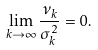Convert formula to latex. <formula><loc_0><loc_0><loc_500><loc_500>\lim _ { k \to \infty } \frac { \nu _ { k } } { \sigma ^ { 2 } _ { k } } = 0 .</formula> 